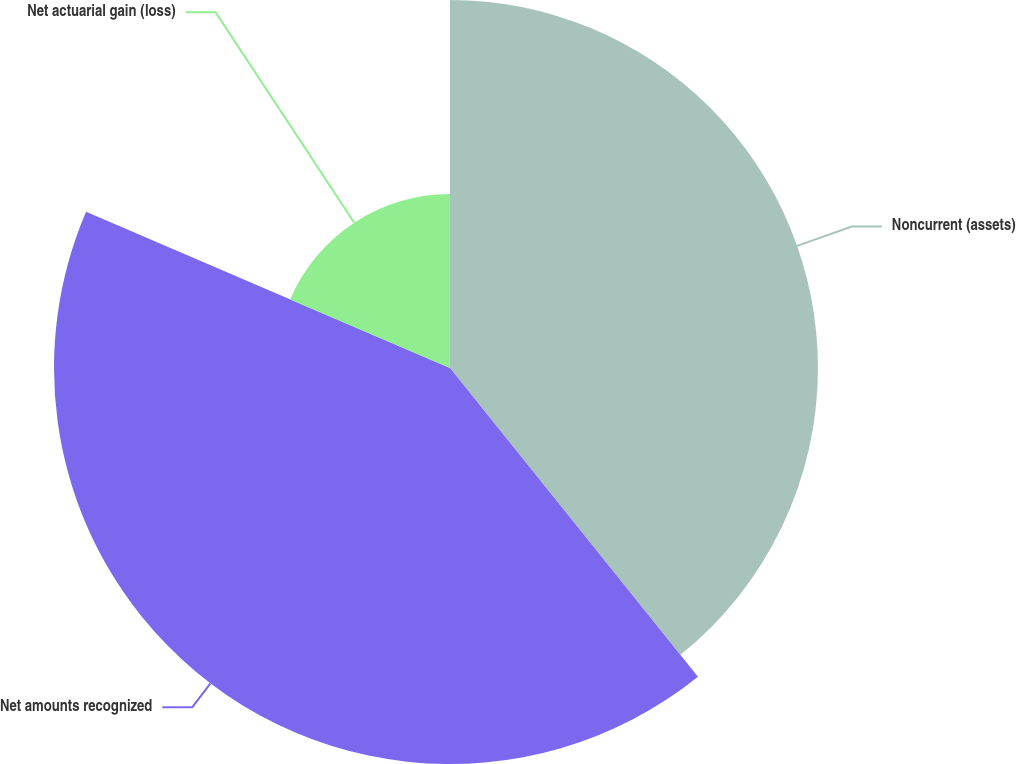Convert chart to OTSL. <chart><loc_0><loc_0><loc_500><loc_500><pie_chart><fcel>Noncurrent (assets)<fcel>Net amounts recognized<fcel>Net actuarial gain (loss)<nl><fcel>39.23%<fcel>42.22%<fcel>18.55%<nl></chart> 